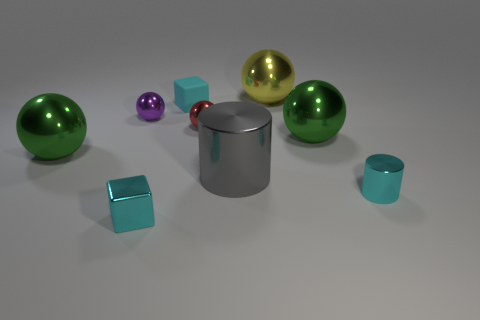Subtract all small spheres. How many spheres are left? 3 Add 1 tiny objects. How many objects exist? 10 Subtract 1 spheres. How many spheres are left? 4 Subtract all yellow balls. How many balls are left? 4 Subtract all purple cylinders. How many green spheres are left? 2 Add 9 purple rubber cylinders. How many purple rubber cylinders exist? 9 Subtract 0 green blocks. How many objects are left? 9 Subtract all blocks. How many objects are left? 7 Subtract all purple blocks. Subtract all yellow cylinders. How many blocks are left? 2 Subtract all large green shiny balls. Subtract all big yellow metallic balls. How many objects are left? 6 